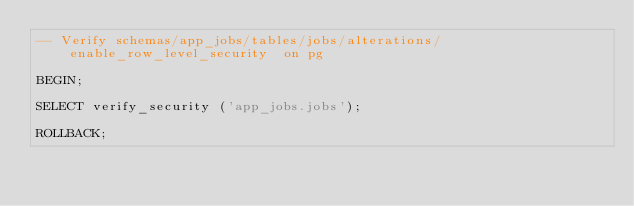<code> <loc_0><loc_0><loc_500><loc_500><_SQL_>-- Verify schemas/app_jobs/tables/jobs/alterations/enable_row_level_security  on pg

BEGIN;

SELECT verify_security ('app_jobs.jobs');

ROLLBACK;
</code> 